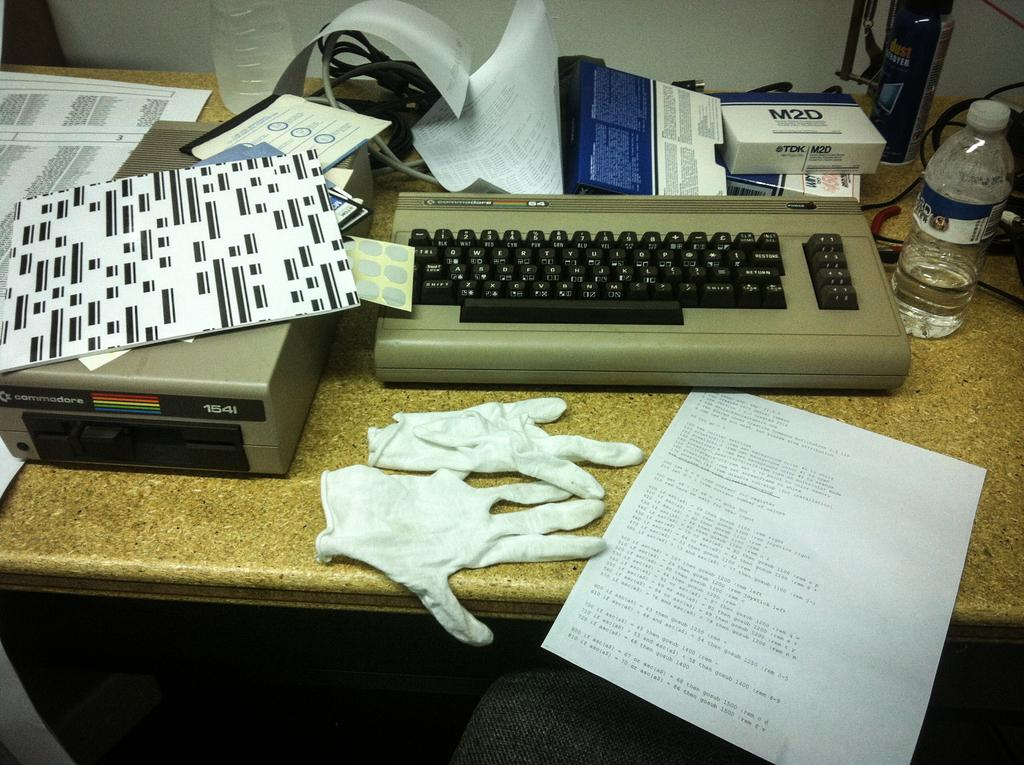<image>
Describe the image concisely. A bunch of junk on a table and a white box that says M2d. 